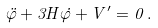<formula> <loc_0><loc_0><loc_500><loc_500>\ddot { \varphi } + 3 H \dot { \varphi } + V ^ { \prime } = 0 \, .</formula> 